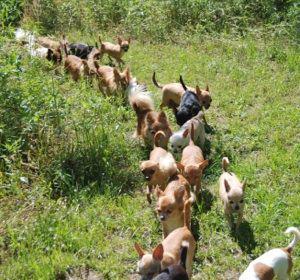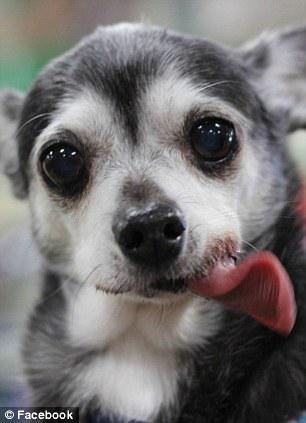The first image is the image on the left, the second image is the image on the right. Considering the images on both sides, is "An image contains a chihuahua snarling and showing its teeth." valid? Answer yes or no. No. 